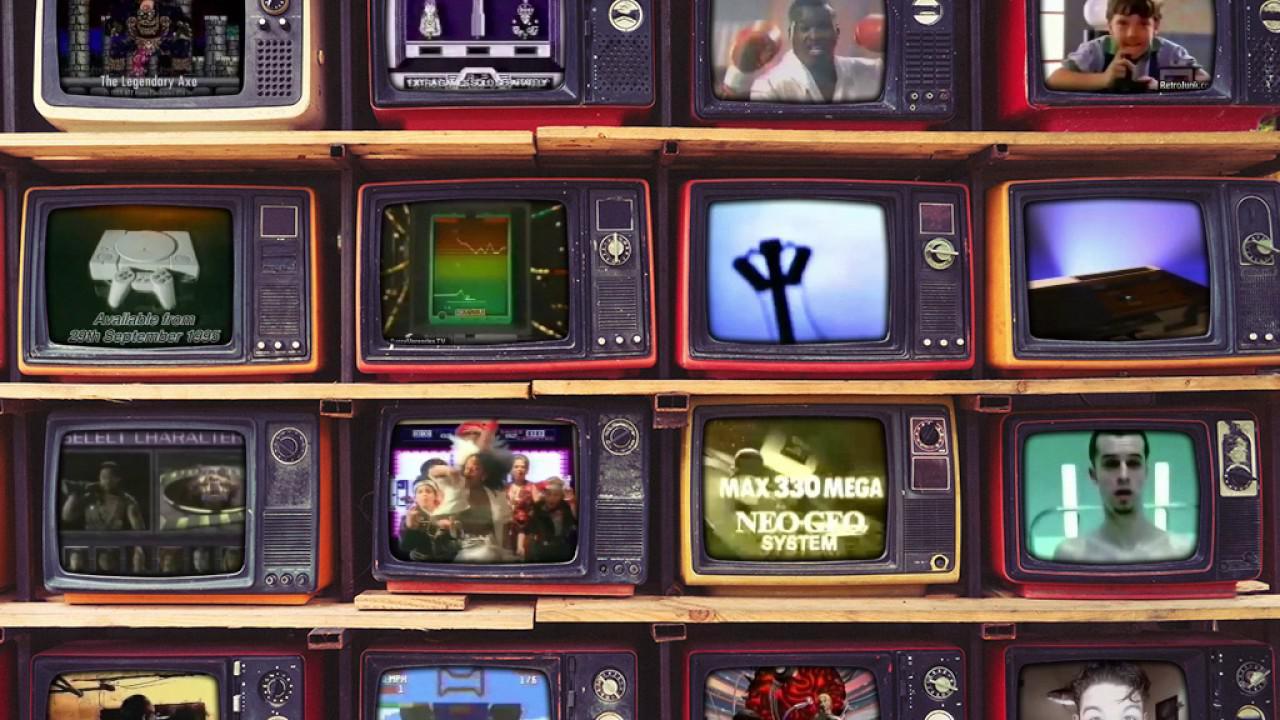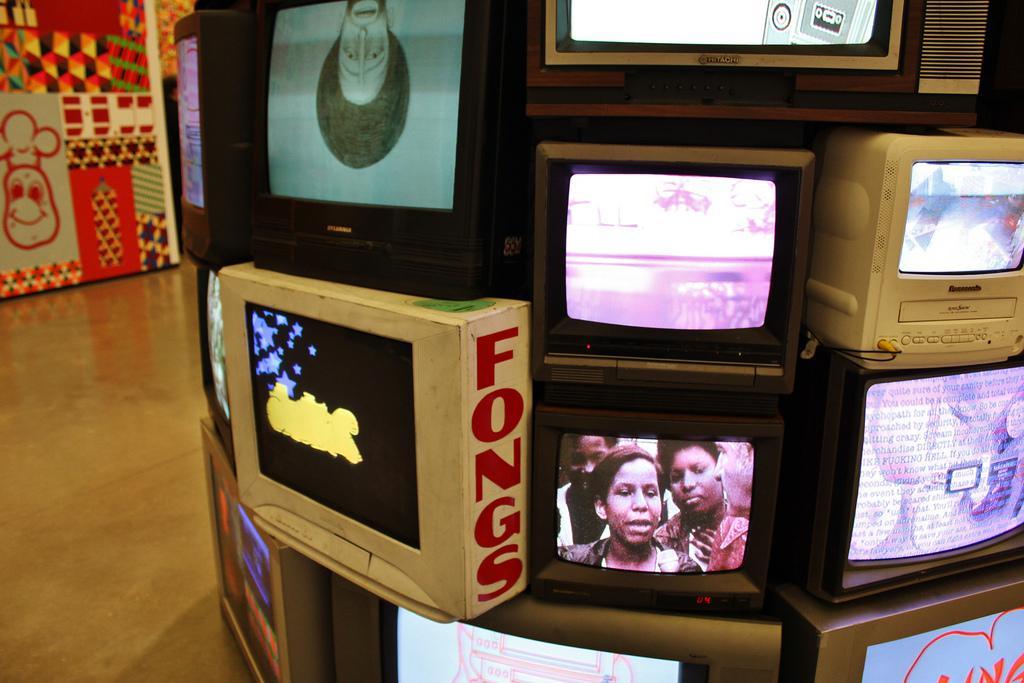The first image is the image on the left, the second image is the image on the right. For the images shown, is this caption "One of the images has less than ten TVs." true? Answer yes or no. Yes. 